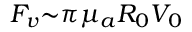<formula> <loc_0><loc_0><loc_500><loc_500>F _ { v } { \sim } { \pi } { \mu } _ { a } R _ { 0 } V _ { 0 }</formula> 